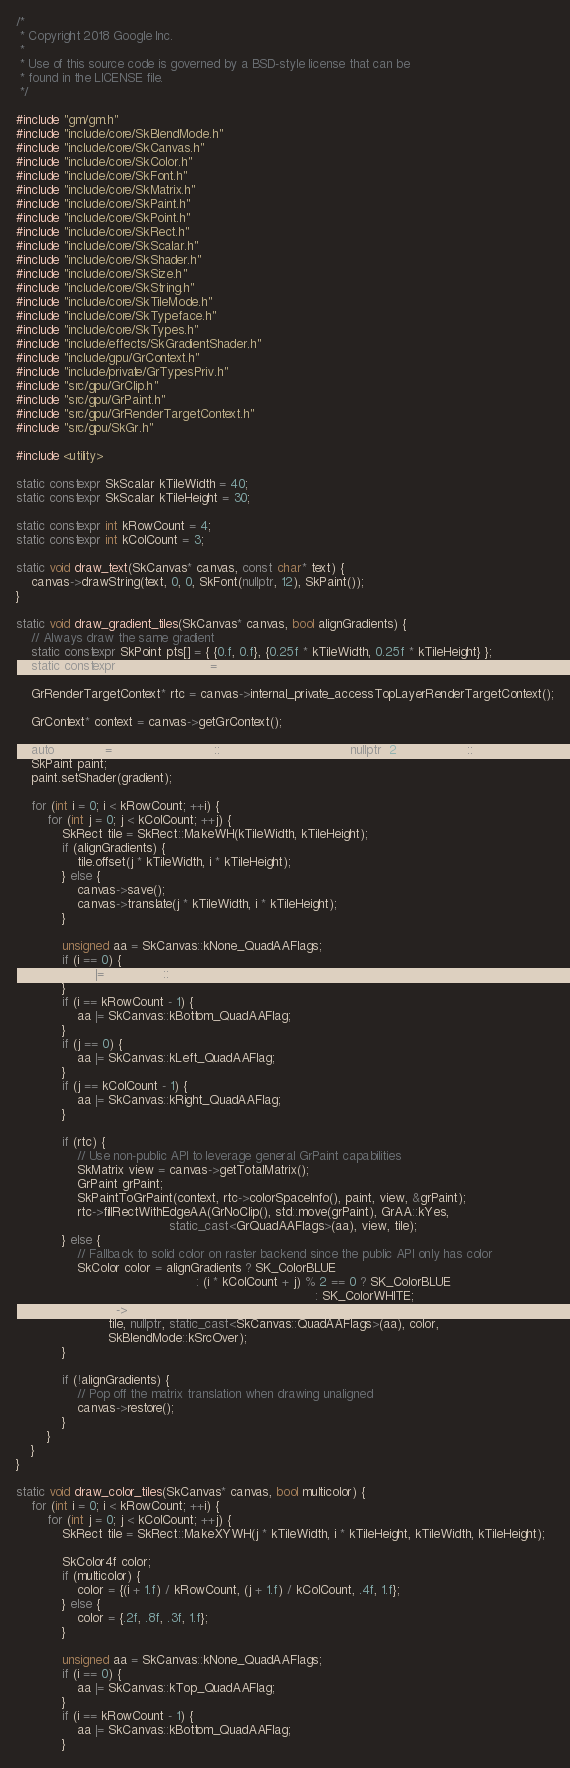<code> <loc_0><loc_0><loc_500><loc_500><_C++_>/*
 * Copyright 2018 Google Inc.
 *
 * Use of this source code is governed by a BSD-style license that can be
 * found in the LICENSE file.
 */

#include "gm/gm.h"
#include "include/core/SkBlendMode.h"
#include "include/core/SkCanvas.h"
#include "include/core/SkColor.h"
#include "include/core/SkFont.h"
#include "include/core/SkMatrix.h"
#include "include/core/SkPaint.h"
#include "include/core/SkPoint.h"
#include "include/core/SkRect.h"
#include "include/core/SkScalar.h"
#include "include/core/SkShader.h"
#include "include/core/SkSize.h"
#include "include/core/SkString.h"
#include "include/core/SkTileMode.h"
#include "include/core/SkTypeface.h"
#include "include/core/SkTypes.h"
#include "include/effects/SkGradientShader.h"
#include "include/gpu/GrContext.h"
#include "include/private/GrTypesPriv.h"
#include "src/gpu/GrClip.h"
#include "src/gpu/GrPaint.h"
#include "src/gpu/GrRenderTargetContext.h"
#include "src/gpu/SkGr.h"

#include <utility>

static constexpr SkScalar kTileWidth = 40;
static constexpr SkScalar kTileHeight = 30;

static constexpr int kRowCount = 4;
static constexpr int kColCount = 3;

static void draw_text(SkCanvas* canvas, const char* text) {
    canvas->drawString(text, 0, 0, SkFont(nullptr, 12), SkPaint());
}

static void draw_gradient_tiles(SkCanvas* canvas, bool alignGradients) {
    // Always draw the same gradient
    static constexpr SkPoint pts[] = { {0.f, 0.f}, {0.25f * kTileWidth, 0.25f * kTileHeight} };
    static constexpr SkColor colors[] = { SK_ColorBLUE, SK_ColorWHITE };

    GrRenderTargetContext* rtc = canvas->internal_private_accessTopLayerRenderTargetContext();

    GrContext* context = canvas->getGrContext();

    auto gradient = SkGradientShader::MakeLinear(pts, colors, nullptr, 2, SkTileMode::kMirror);
    SkPaint paint;
    paint.setShader(gradient);

    for (int i = 0; i < kRowCount; ++i) {
        for (int j = 0; j < kColCount; ++j) {
            SkRect tile = SkRect::MakeWH(kTileWidth, kTileHeight);
            if (alignGradients) {
                tile.offset(j * kTileWidth, i * kTileHeight);
            } else {
                canvas->save();
                canvas->translate(j * kTileWidth, i * kTileHeight);
            }

            unsigned aa = SkCanvas::kNone_QuadAAFlags;
            if (i == 0) {
                aa |= SkCanvas::kTop_QuadAAFlag;
            }
            if (i == kRowCount - 1) {
                aa |= SkCanvas::kBottom_QuadAAFlag;
            }
            if (j == 0) {
                aa |= SkCanvas::kLeft_QuadAAFlag;
            }
            if (j == kColCount - 1) {
                aa |= SkCanvas::kRight_QuadAAFlag;
            }

            if (rtc) {
                // Use non-public API to leverage general GrPaint capabilities
                SkMatrix view = canvas->getTotalMatrix();
                GrPaint grPaint;
                SkPaintToGrPaint(context, rtc->colorSpaceInfo(), paint, view, &grPaint);
                rtc->fillRectWithEdgeAA(GrNoClip(), std::move(grPaint), GrAA::kYes,
                                        static_cast<GrQuadAAFlags>(aa), view, tile);
            } else {
                // Fallback to solid color on raster backend since the public API only has color
                SkColor color = alignGradients ? SK_ColorBLUE
                                               : (i * kColCount + j) % 2 == 0 ? SK_ColorBLUE
                                                                              : SK_ColorWHITE;
                canvas->experimental_DrawEdgeAAQuad(
                        tile, nullptr, static_cast<SkCanvas::QuadAAFlags>(aa), color,
                        SkBlendMode::kSrcOver);
            }

            if (!alignGradients) {
                // Pop off the matrix translation when drawing unaligned
                canvas->restore();
            }
        }
    }
}

static void draw_color_tiles(SkCanvas* canvas, bool multicolor) {
    for (int i = 0; i < kRowCount; ++i) {
        for (int j = 0; j < kColCount; ++j) {
            SkRect tile = SkRect::MakeXYWH(j * kTileWidth, i * kTileHeight, kTileWidth, kTileHeight);

            SkColor4f color;
            if (multicolor) {
                color = {(i + 1.f) / kRowCount, (j + 1.f) / kColCount, .4f, 1.f};
            } else {
                color = {.2f, .8f, .3f, 1.f};
            }

            unsigned aa = SkCanvas::kNone_QuadAAFlags;
            if (i == 0) {
                aa |= SkCanvas::kTop_QuadAAFlag;
            }
            if (i == kRowCount - 1) {
                aa |= SkCanvas::kBottom_QuadAAFlag;
            }</code> 